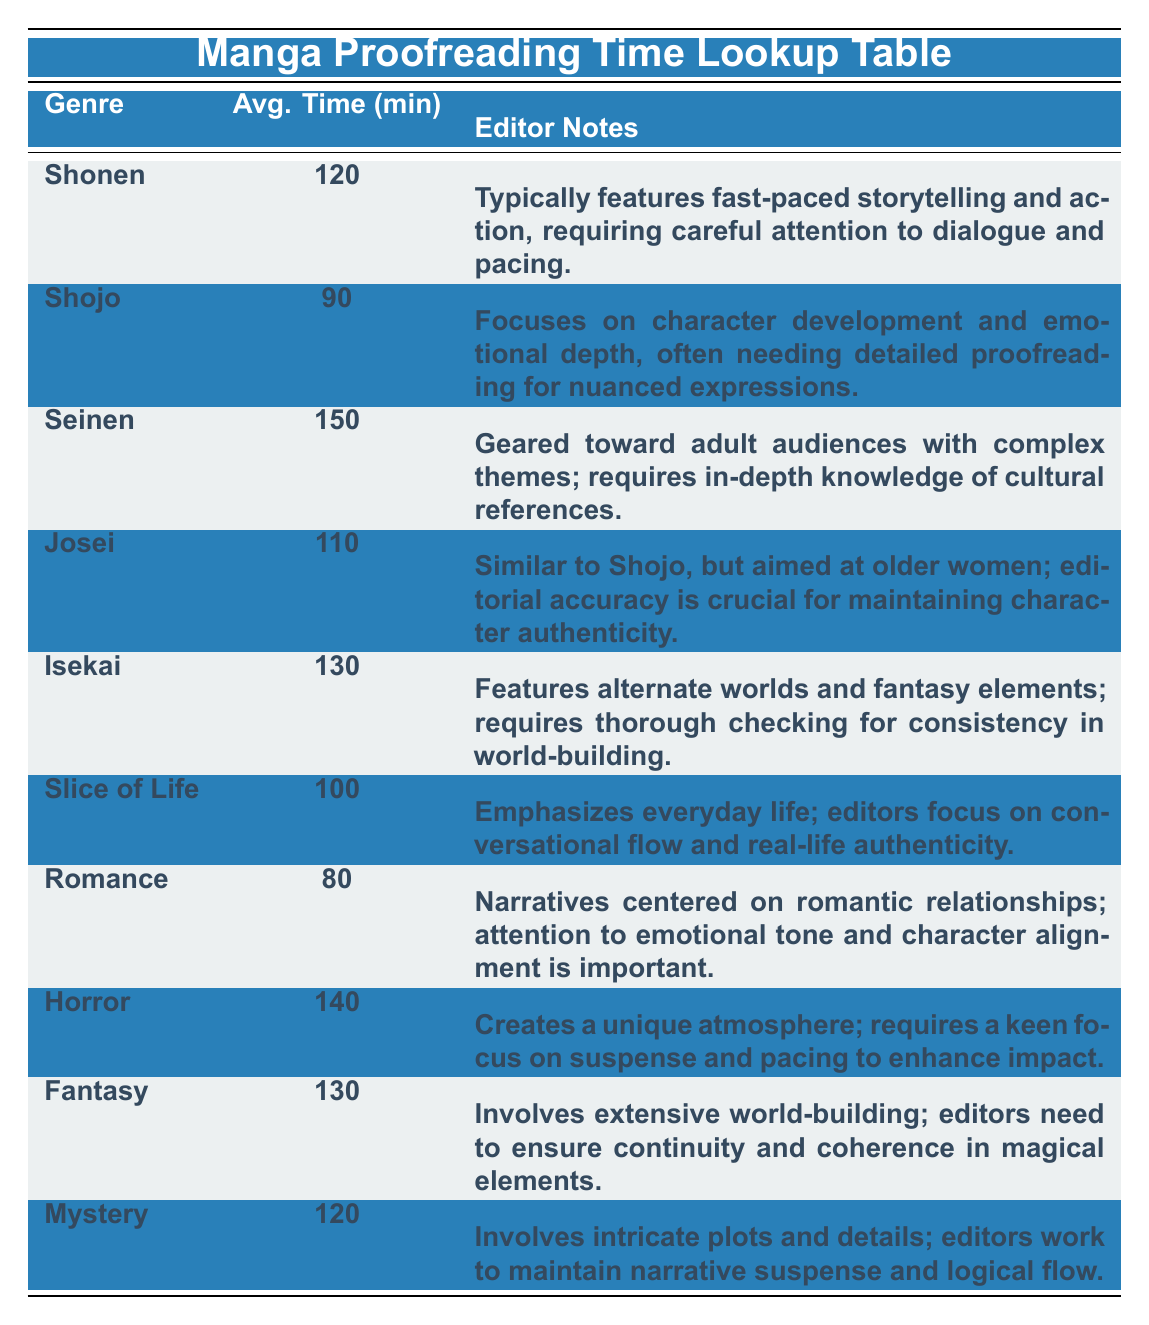What is the average time spent by editors on proofreading Shonen manga? According to the table, the average time spent on Shonen manga is clearly listed as 120 minutes.
Answer: 120 minutes Which genre has the highest average time spent on proofreading? By reviewing the average times for each genre in the table, Seinen with 150 minutes has the highest value compared to the others.
Answer: Seinen How much more time, on average, do editors spend on proofreading Horror compared to Romance? The average time for Horror is 140 minutes and for Romance is 80 minutes. Subtracting these gives 140 - 80 = 60 minutes more for Horror.
Answer: 60 minutes Is it true that editors spend less time proofreading Shojo compared to Slice of Life? The average time for Shojo is 90 minutes, and for Slice of Life, it is 100 minutes. Since 90 is less than 100, the statement is true.
Answer: Yes If we sum the average times of Isekai, Fantasy, and Josei, what is the total? The average time for Isekai is 130 minutes, Fantasy is 130 minutes, and Josei is 110 minutes. Adding these gives 130 + 130 + 110 = 370 minutes total.
Answer: 370 minutes What is the median average time spent across all genres? Arranging the average times in ascending order: 80, 90, 100, 110, 120, 120, 130, 130, 140, 150. The median is the average of the 5th and 6th values, (120 + 120)/2 = 120.
Answer: 120 minutes Which genre requires the most focus on narrative suspense and logical flow? The table indicates that Mystery involves intricate plots and details, where editors focus on maintaining suspense and logical flow, making it the genre in question.
Answer: Mystery Do editors spend the least amount of time proofreading Romance? Romance has the lowest average time of 80 minutes compared to the other genres listed in the table, confirming this statement is true.
Answer: Yes 